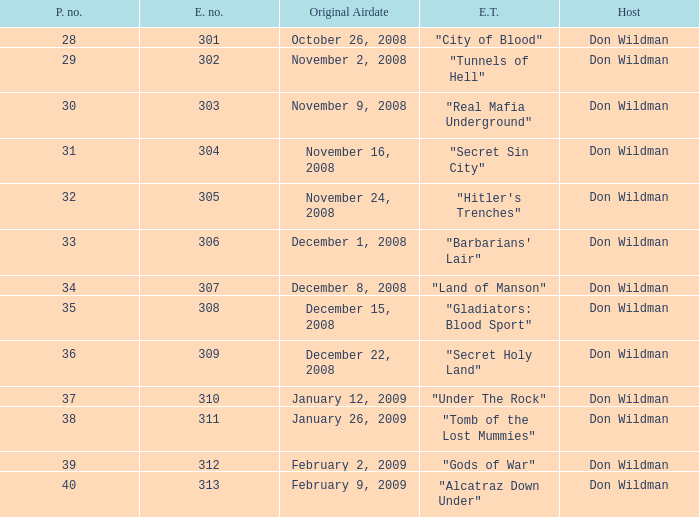What is the episode number of the episode that originally aired on January 26, 2009 and had a production number smaller than 38? 0.0. 